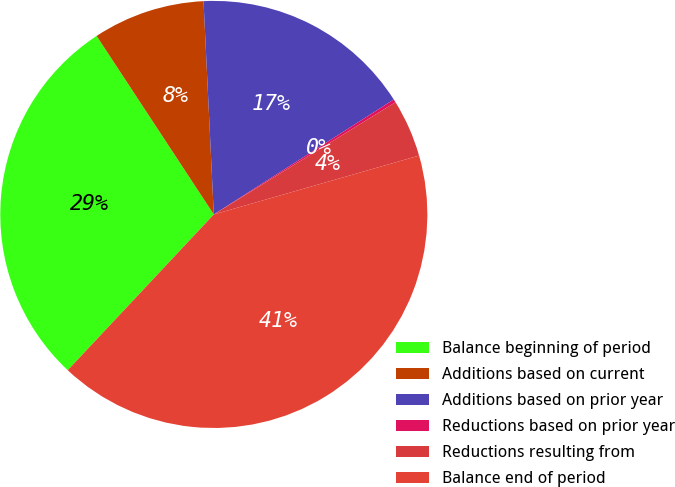Convert chart. <chart><loc_0><loc_0><loc_500><loc_500><pie_chart><fcel>Balance beginning of period<fcel>Additions based on current<fcel>Additions based on prior year<fcel>Reductions based on prior year<fcel>Reductions resulting from<fcel>Balance end of period<nl><fcel>28.76%<fcel>8.48%<fcel>16.72%<fcel>0.24%<fcel>4.36%<fcel>41.43%<nl></chart> 